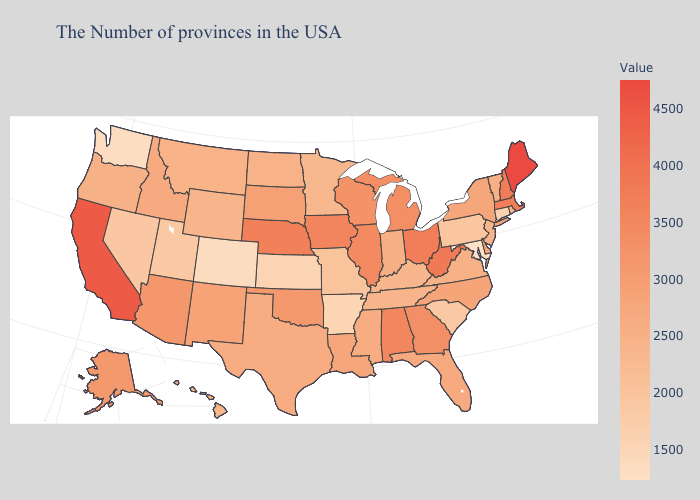Among the states that border Arkansas , does Missouri have the lowest value?
Answer briefly. Yes. Which states hav the highest value in the South?
Short answer required. West Virginia. Which states have the highest value in the USA?
Be succinct. Maine. Does South Dakota have a higher value than Washington?
Write a very short answer. Yes. 